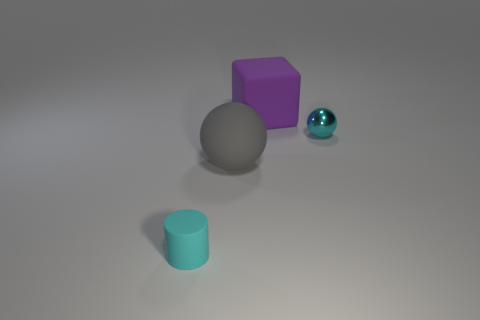Is the number of small cyan metal objects that are right of the small cyan sphere less than the number of tiny cyan objects left of the purple matte cube?
Your response must be concise. Yes. There is a tiny thing that is right of the big purple thing; is it the same color as the small object on the left side of the large gray sphere?
Your answer should be very brief. Yes. There is a object that is both behind the big ball and in front of the large purple rubber block; what is its material?
Provide a succinct answer. Metal. Is there a gray rubber cylinder?
Give a very brief answer. No. The cyan thing that is the same material as the purple cube is what shape?
Offer a terse response. Cylinder. There is a tiny shiny thing; is its shape the same as the small cyan thing in front of the gray rubber thing?
Provide a succinct answer. No. What is the cyan thing that is behind the small cyan thing left of the gray sphere made of?
Make the answer very short. Metal. How many other things are there of the same shape as the large gray thing?
Ensure brevity in your answer.  1. There is a cyan object to the right of the large rubber sphere; is it the same shape as the large matte object that is in front of the big cube?
Your response must be concise. Yes. Is there any other thing that has the same material as the small cyan sphere?
Offer a terse response. No. 